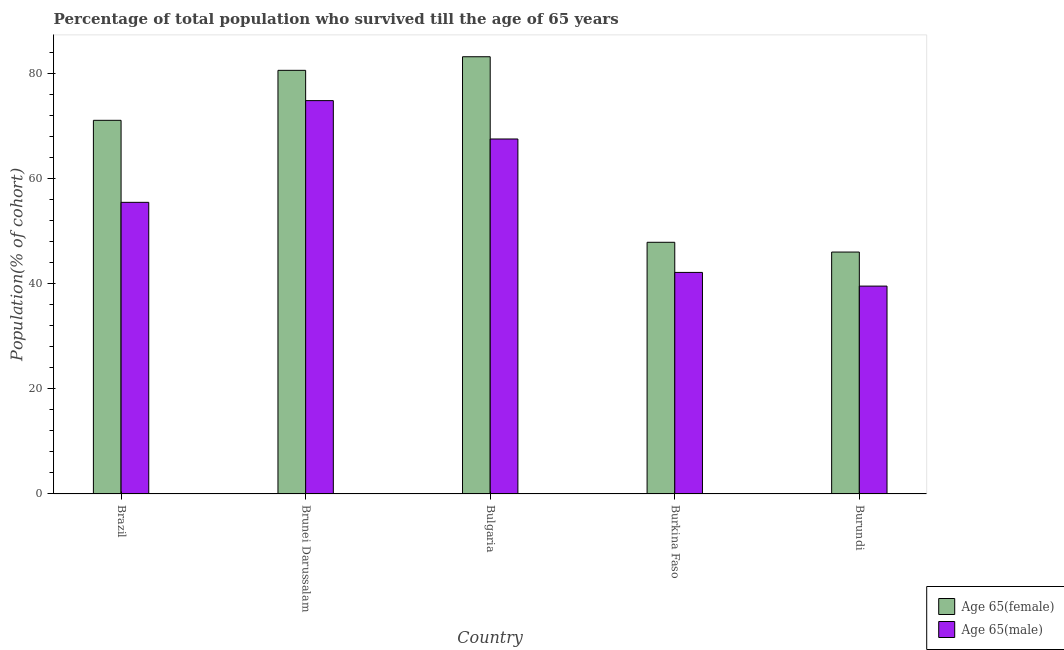How many different coloured bars are there?
Your response must be concise. 2. Are the number of bars per tick equal to the number of legend labels?
Provide a short and direct response. Yes. Are the number of bars on each tick of the X-axis equal?
Provide a succinct answer. Yes. How many bars are there on the 5th tick from the left?
Provide a short and direct response. 2. How many bars are there on the 1st tick from the right?
Make the answer very short. 2. What is the label of the 5th group of bars from the left?
Provide a succinct answer. Burundi. In how many cases, is the number of bars for a given country not equal to the number of legend labels?
Give a very brief answer. 0. What is the percentage of male population who survived till age of 65 in Brazil?
Provide a short and direct response. 55.54. Across all countries, what is the maximum percentage of male population who survived till age of 65?
Offer a very short reply. 74.92. Across all countries, what is the minimum percentage of male population who survived till age of 65?
Give a very brief answer. 39.59. In which country was the percentage of male population who survived till age of 65 maximum?
Provide a short and direct response. Brunei Darussalam. In which country was the percentage of male population who survived till age of 65 minimum?
Keep it short and to the point. Burundi. What is the total percentage of female population who survived till age of 65 in the graph?
Make the answer very short. 329.13. What is the difference between the percentage of male population who survived till age of 65 in Brazil and that in Bulgaria?
Provide a succinct answer. -12.06. What is the difference between the percentage of female population who survived till age of 65 in Burkina Faso and the percentage of male population who survived till age of 65 in Brazil?
Ensure brevity in your answer.  -7.61. What is the average percentage of female population who survived till age of 65 per country?
Make the answer very short. 65.83. What is the difference between the percentage of female population who survived till age of 65 and percentage of male population who survived till age of 65 in Bulgaria?
Provide a succinct answer. 15.67. What is the ratio of the percentage of female population who survived till age of 65 in Brazil to that in Burundi?
Provide a short and direct response. 1.54. Is the percentage of male population who survived till age of 65 in Brazil less than that in Burkina Faso?
Ensure brevity in your answer.  No. What is the difference between the highest and the second highest percentage of female population who survived till age of 65?
Your answer should be compact. 2.59. What is the difference between the highest and the lowest percentage of female population who survived till age of 65?
Your answer should be very brief. 37.2. Is the sum of the percentage of male population who survived till age of 65 in Bulgaria and Burkina Faso greater than the maximum percentage of female population who survived till age of 65 across all countries?
Provide a succinct answer. Yes. What does the 1st bar from the left in Brazil represents?
Your answer should be very brief. Age 65(female). What does the 1st bar from the right in Brazil represents?
Provide a succinct answer. Age 65(male). What is the difference between two consecutive major ticks on the Y-axis?
Your answer should be compact. 20. Does the graph contain grids?
Offer a terse response. No. How many legend labels are there?
Ensure brevity in your answer.  2. What is the title of the graph?
Keep it short and to the point. Percentage of total population who survived till the age of 65 years. What is the label or title of the Y-axis?
Your answer should be compact. Population(% of cohort). What is the Population(% of cohort) of Age 65(female) in Brazil?
Keep it short and to the point. 71.17. What is the Population(% of cohort) in Age 65(male) in Brazil?
Give a very brief answer. 55.54. What is the Population(% of cohort) in Age 65(female) in Brunei Darussalam?
Your response must be concise. 80.68. What is the Population(% of cohort) in Age 65(male) in Brunei Darussalam?
Offer a very short reply. 74.92. What is the Population(% of cohort) of Age 65(female) in Bulgaria?
Make the answer very short. 83.27. What is the Population(% of cohort) of Age 65(male) in Bulgaria?
Provide a succinct answer. 67.61. What is the Population(% of cohort) of Age 65(female) in Burkina Faso?
Give a very brief answer. 47.94. What is the Population(% of cohort) of Age 65(male) in Burkina Faso?
Give a very brief answer. 42.2. What is the Population(% of cohort) of Age 65(female) in Burundi?
Your answer should be very brief. 46.07. What is the Population(% of cohort) in Age 65(male) in Burundi?
Provide a succinct answer. 39.59. Across all countries, what is the maximum Population(% of cohort) in Age 65(female)?
Your answer should be compact. 83.27. Across all countries, what is the maximum Population(% of cohort) of Age 65(male)?
Provide a succinct answer. 74.92. Across all countries, what is the minimum Population(% of cohort) in Age 65(female)?
Your answer should be very brief. 46.07. Across all countries, what is the minimum Population(% of cohort) in Age 65(male)?
Ensure brevity in your answer.  39.59. What is the total Population(% of cohort) in Age 65(female) in the graph?
Your answer should be compact. 329.13. What is the total Population(% of cohort) of Age 65(male) in the graph?
Ensure brevity in your answer.  279.86. What is the difference between the Population(% of cohort) in Age 65(female) in Brazil and that in Brunei Darussalam?
Provide a short and direct response. -9.52. What is the difference between the Population(% of cohort) in Age 65(male) in Brazil and that in Brunei Darussalam?
Your response must be concise. -19.37. What is the difference between the Population(% of cohort) in Age 65(female) in Brazil and that in Bulgaria?
Make the answer very short. -12.11. What is the difference between the Population(% of cohort) in Age 65(male) in Brazil and that in Bulgaria?
Your answer should be compact. -12.06. What is the difference between the Population(% of cohort) in Age 65(female) in Brazil and that in Burkina Faso?
Give a very brief answer. 23.23. What is the difference between the Population(% of cohort) in Age 65(male) in Brazil and that in Burkina Faso?
Ensure brevity in your answer.  13.35. What is the difference between the Population(% of cohort) of Age 65(female) in Brazil and that in Burundi?
Offer a terse response. 25.09. What is the difference between the Population(% of cohort) of Age 65(male) in Brazil and that in Burundi?
Offer a terse response. 15.95. What is the difference between the Population(% of cohort) in Age 65(female) in Brunei Darussalam and that in Bulgaria?
Your response must be concise. -2.59. What is the difference between the Population(% of cohort) of Age 65(male) in Brunei Darussalam and that in Bulgaria?
Your answer should be very brief. 7.31. What is the difference between the Population(% of cohort) of Age 65(female) in Brunei Darussalam and that in Burkina Faso?
Give a very brief answer. 32.75. What is the difference between the Population(% of cohort) of Age 65(male) in Brunei Darussalam and that in Burkina Faso?
Offer a very short reply. 32.72. What is the difference between the Population(% of cohort) in Age 65(female) in Brunei Darussalam and that in Burundi?
Offer a very short reply. 34.61. What is the difference between the Population(% of cohort) of Age 65(male) in Brunei Darussalam and that in Burundi?
Make the answer very short. 35.33. What is the difference between the Population(% of cohort) in Age 65(female) in Bulgaria and that in Burkina Faso?
Your answer should be compact. 35.34. What is the difference between the Population(% of cohort) of Age 65(male) in Bulgaria and that in Burkina Faso?
Make the answer very short. 25.41. What is the difference between the Population(% of cohort) in Age 65(female) in Bulgaria and that in Burundi?
Make the answer very short. 37.2. What is the difference between the Population(% of cohort) of Age 65(male) in Bulgaria and that in Burundi?
Provide a succinct answer. 28.02. What is the difference between the Population(% of cohort) of Age 65(female) in Burkina Faso and that in Burundi?
Offer a terse response. 1.86. What is the difference between the Population(% of cohort) in Age 65(male) in Burkina Faso and that in Burundi?
Offer a terse response. 2.6. What is the difference between the Population(% of cohort) of Age 65(female) in Brazil and the Population(% of cohort) of Age 65(male) in Brunei Darussalam?
Provide a short and direct response. -3.75. What is the difference between the Population(% of cohort) in Age 65(female) in Brazil and the Population(% of cohort) in Age 65(male) in Bulgaria?
Your answer should be very brief. 3.56. What is the difference between the Population(% of cohort) in Age 65(female) in Brazil and the Population(% of cohort) in Age 65(male) in Burkina Faso?
Offer a very short reply. 28.97. What is the difference between the Population(% of cohort) of Age 65(female) in Brazil and the Population(% of cohort) of Age 65(male) in Burundi?
Give a very brief answer. 31.57. What is the difference between the Population(% of cohort) in Age 65(female) in Brunei Darussalam and the Population(% of cohort) in Age 65(male) in Bulgaria?
Offer a terse response. 13.08. What is the difference between the Population(% of cohort) in Age 65(female) in Brunei Darussalam and the Population(% of cohort) in Age 65(male) in Burkina Faso?
Give a very brief answer. 38.49. What is the difference between the Population(% of cohort) of Age 65(female) in Brunei Darussalam and the Population(% of cohort) of Age 65(male) in Burundi?
Keep it short and to the point. 41.09. What is the difference between the Population(% of cohort) of Age 65(female) in Bulgaria and the Population(% of cohort) of Age 65(male) in Burkina Faso?
Keep it short and to the point. 41.08. What is the difference between the Population(% of cohort) in Age 65(female) in Bulgaria and the Population(% of cohort) in Age 65(male) in Burundi?
Provide a succinct answer. 43.68. What is the difference between the Population(% of cohort) of Age 65(female) in Burkina Faso and the Population(% of cohort) of Age 65(male) in Burundi?
Your answer should be compact. 8.34. What is the average Population(% of cohort) of Age 65(female) per country?
Your response must be concise. 65.83. What is the average Population(% of cohort) of Age 65(male) per country?
Your response must be concise. 55.97. What is the difference between the Population(% of cohort) in Age 65(female) and Population(% of cohort) in Age 65(male) in Brazil?
Offer a very short reply. 15.62. What is the difference between the Population(% of cohort) of Age 65(female) and Population(% of cohort) of Age 65(male) in Brunei Darussalam?
Provide a succinct answer. 5.77. What is the difference between the Population(% of cohort) in Age 65(female) and Population(% of cohort) in Age 65(male) in Bulgaria?
Provide a short and direct response. 15.67. What is the difference between the Population(% of cohort) of Age 65(female) and Population(% of cohort) of Age 65(male) in Burkina Faso?
Your answer should be compact. 5.74. What is the difference between the Population(% of cohort) in Age 65(female) and Population(% of cohort) in Age 65(male) in Burundi?
Your answer should be very brief. 6.48. What is the ratio of the Population(% of cohort) in Age 65(female) in Brazil to that in Brunei Darussalam?
Your response must be concise. 0.88. What is the ratio of the Population(% of cohort) of Age 65(male) in Brazil to that in Brunei Darussalam?
Offer a terse response. 0.74. What is the ratio of the Population(% of cohort) of Age 65(female) in Brazil to that in Bulgaria?
Your answer should be compact. 0.85. What is the ratio of the Population(% of cohort) in Age 65(male) in Brazil to that in Bulgaria?
Offer a terse response. 0.82. What is the ratio of the Population(% of cohort) in Age 65(female) in Brazil to that in Burkina Faso?
Your answer should be very brief. 1.48. What is the ratio of the Population(% of cohort) of Age 65(male) in Brazil to that in Burkina Faso?
Provide a succinct answer. 1.32. What is the ratio of the Population(% of cohort) of Age 65(female) in Brazil to that in Burundi?
Your answer should be compact. 1.54. What is the ratio of the Population(% of cohort) in Age 65(male) in Brazil to that in Burundi?
Keep it short and to the point. 1.4. What is the ratio of the Population(% of cohort) of Age 65(female) in Brunei Darussalam to that in Bulgaria?
Provide a succinct answer. 0.97. What is the ratio of the Population(% of cohort) of Age 65(male) in Brunei Darussalam to that in Bulgaria?
Your answer should be very brief. 1.11. What is the ratio of the Population(% of cohort) of Age 65(female) in Brunei Darussalam to that in Burkina Faso?
Your answer should be very brief. 1.68. What is the ratio of the Population(% of cohort) of Age 65(male) in Brunei Darussalam to that in Burkina Faso?
Keep it short and to the point. 1.78. What is the ratio of the Population(% of cohort) in Age 65(female) in Brunei Darussalam to that in Burundi?
Your response must be concise. 1.75. What is the ratio of the Population(% of cohort) in Age 65(male) in Brunei Darussalam to that in Burundi?
Give a very brief answer. 1.89. What is the ratio of the Population(% of cohort) in Age 65(female) in Bulgaria to that in Burkina Faso?
Your answer should be compact. 1.74. What is the ratio of the Population(% of cohort) in Age 65(male) in Bulgaria to that in Burkina Faso?
Make the answer very short. 1.6. What is the ratio of the Population(% of cohort) in Age 65(female) in Bulgaria to that in Burundi?
Ensure brevity in your answer.  1.81. What is the ratio of the Population(% of cohort) in Age 65(male) in Bulgaria to that in Burundi?
Your response must be concise. 1.71. What is the ratio of the Population(% of cohort) of Age 65(female) in Burkina Faso to that in Burundi?
Make the answer very short. 1.04. What is the ratio of the Population(% of cohort) of Age 65(male) in Burkina Faso to that in Burundi?
Your answer should be compact. 1.07. What is the difference between the highest and the second highest Population(% of cohort) of Age 65(female)?
Give a very brief answer. 2.59. What is the difference between the highest and the second highest Population(% of cohort) of Age 65(male)?
Ensure brevity in your answer.  7.31. What is the difference between the highest and the lowest Population(% of cohort) of Age 65(female)?
Offer a terse response. 37.2. What is the difference between the highest and the lowest Population(% of cohort) in Age 65(male)?
Your answer should be very brief. 35.33. 